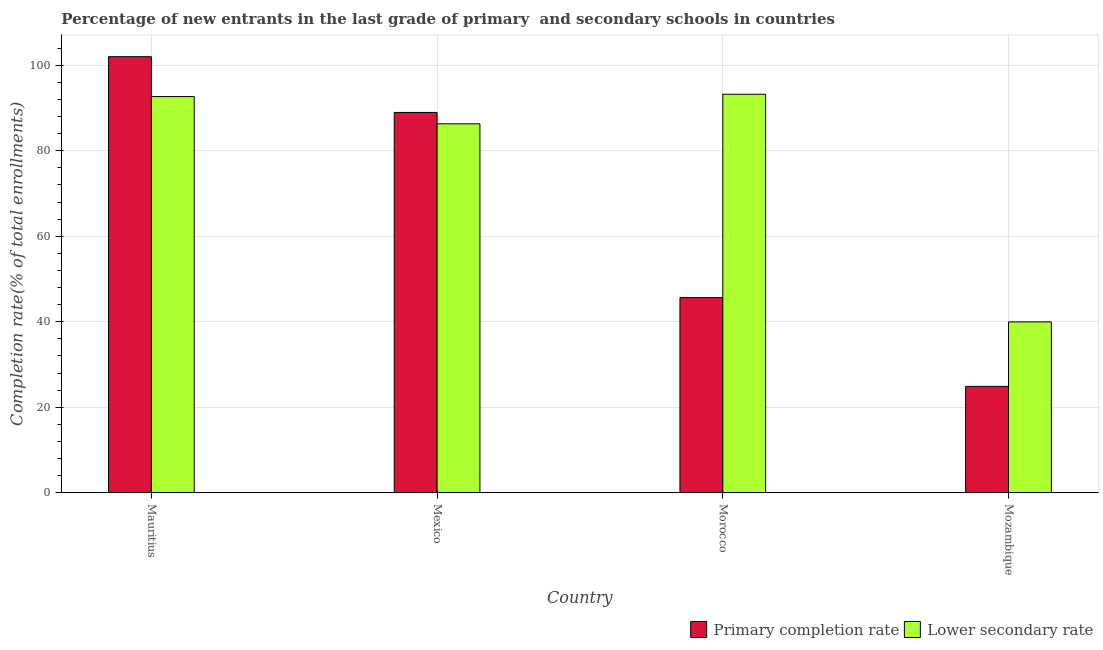Are the number of bars on each tick of the X-axis equal?
Offer a very short reply. Yes. How many bars are there on the 1st tick from the right?
Make the answer very short. 2. What is the completion rate in secondary schools in Morocco?
Your answer should be compact. 93.21. Across all countries, what is the maximum completion rate in secondary schools?
Give a very brief answer. 93.21. Across all countries, what is the minimum completion rate in primary schools?
Offer a terse response. 24.87. In which country was the completion rate in secondary schools maximum?
Keep it short and to the point. Morocco. In which country was the completion rate in secondary schools minimum?
Give a very brief answer. Mozambique. What is the total completion rate in primary schools in the graph?
Make the answer very short. 261.47. What is the difference between the completion rate in primary schools in Morocco and that in Mozambique?
Keep it short and to the point. 20.77. What is the difference between the completion rate in secondary schools in Mexico and the completion rate in primary schools in Mozambique?
Your answer should be compact. 61.42. What is the average completion rate in secondary schools per country?
Keep it short and to the point. 78.03. What is the difference between the completion rate in secondary schools and completion rate in primary schools in Mauritius?
Your answer should be compact. -9.34. In how many countries, is the completion rate in secondary schools greater than 28 %?
Offer a terse response. 4. What is the ratio of the completion rate in primary schools in Mauritius to that in Mexico?
Offer a terse response. 1.15. Is the difference between the completion rate in primary schools in Morocco and Mozambique greater than the difference between the completion rate in secondary schools in Morocco and Mozambique?
Your response must be concise. No. What is the difference between the highest and the second highest completion rate in primary schools?
Offer a very short reply. 13.05. What is the difference between the highest and the lowest completion rate in secondary schools?
Provide a succinct answer. 53.25. Is the sum of the completion rate in primary schools in Morocco and Mozambique greater than the maximum completion rate in secondary schools across all countries?
Provide a succinct answer. No. What does the 1st bar from the left in Mozambique represents?
Offer a terse response. Primary completion rate. What does the 1st bar from the right in Mauritius represents?
Offer a terse response. Lower secondary rate. Are all the bars in the graph horizontal?
Make the answer very short. No. How many countries are there in the graph?
Keep it short and to the point. 4. Are the values on the major ticks of Y-axis written in scientific E-notation?
Make the answer very short. No. Does the graph contain any zero values?
Your answer should be compact. No. Does the graph contain grids?
Ensure brevity in your answer.  Yes. Where does the legend appear in the graph?
Provide a short and direct response. Bottom right. What is the title of the graph?
Give a very brief answer. Percentage of new entrants in the last grade of primary  and secondary schools in countries. Does "Residents" appear as one of the legend labels in the graph?
Offer a terse response. No. What is the label or title of the X-axis?
Offer a very short reply. Country. What is the label or title of the Y-axis?
Offer a very short reply. Completion rate(% of total enrollments). What is the Completion rate(% of total enrollments) in Primary completion rate in Mauritius?
Give a very brief answer. 102. What is the Completion rate(% of total enrollments) of Lower secondary rate in Mauritius?
Keep it short and to the point. 92.66. What is the Completion rate(% of total enrollments) of Primary completion rate in Mexico?
Your response must be concise. 88.95. What is the Completion rate(% of total enrollments) in Lower secondary rate in Mexico?
Your answer should be compact. 86.3. What is the Completion rate(% of total enrollments) of Primary completion rate in Morocco?
Offer a terse response. 45.65. What is the Completion rate(% of total enrollments) of Lower secondary rate in Morocco?
Your answer should be compact. 93.21. What is the Completion rate(% of total enrollments) of Primary completion rate in Mozambique?
Your response must be concise. 24.87. What is the Completion rate(% of total enrollments) in Lower secondary rate in Mozambique?
Ensure brevity in your answer.  39.96. Across all countries, what is the maximum Completion rate(% of total enrollments) of Primary completion rate?
Keep it short and to the point. 102. Across all countries, what is the maximum Completion rate(% of total enrollments) in Lower secondary rate?
Give a very brief answer. 93.21. Across all countries, what is the minimum Completion rate(% of total enrollments) in Primary completion rate?
Offer a very short reply. 24.87. Across all countries, what is the minimum Completion rate(% of total enrollments) of Lower secondary rate?
Your answer should be very brief. 39.96. What is the total Completion rate(% of total enrollments) in Primary completion rate in the graph?
Your answer should be compact. 261.47. What is the total Completion rate(% of total enrollments) in Lower secondary rate in the graph?
Make the answer very short. 312.13. What is the difference between the Completion rate(% of total enrollments) of Primary completion rate in Mauritius and that in Mexico?
Provide a short and direct response. 13.05. What is the difference between the Completion rate(% of total enrollments) in Lower secondary rate in Mauritius and that in Mexico?
Your answer should be very brief. 6.36. What is the difference between the Completion rate(% of total enrollments) of Primary completion rate in Mauritius and that in Morocco?
Make the answer very short. 56.35. What is the difference between the Completion rate(% of total enrollments) of Lower secondary rate in Mauritius and that in Morocco?
Provide a short and direct response. -0.55. What is the difference between the Completion rate(% of total enrollments) in Primary completion rate in Mauritius and that in Mozambique?
Your response must be concise. 77.13. What is the difference between the Completion rate(% of total enrollments) of Lower secondary rate in Mauritius and that in Mozambique?
Keep it short and to the point. 52.7. What is the difference between the Completion rate(% of total enrollments) of Primary completion rate in Mexico and that in Morocco?
Your response must be concise. 43.31. What is the difference between the Completion rate(% of total enrollments) in Lower secondary rate in Mexico and that in Morocco?
Ensure brevity in your answer.  -6.91. What is the difference between the Completion rate(% of total enrollments) in Primary completion rate in Mexico and that in Mozambique?
Keep it short and to the point. 64.08. What is the difference between the Completion rate(% of total enrollments) of Lower secondary rate in Mexico and that in Mozambique?
Keep it short and to the point. 46.34. What is the difference between the Completion rate(% of total enrollments) of Primary completion rate in Morocco and that in Mozambique?
Offer a terse response. 20.77. What is the difference between the Completion rate(% of total enrollments) of Lower secondary rate in Morocco and that in Mozambique?
Your answer should be very brief. 53.25. What is the difference between the Completion rate(% of total enrollments) in Primary completion rate in Mauritius and the Completion rate(% of total enrollments) in Lower secondary rate in Mexico?
Give a very brief answer. 15.7. What is the difference between the Completion rate(% of total enrollments) in Primary completion rate in Mauritius and the Completion rate(% of total enrollments) in Lower secondary rate in Morocco?
Ensure brevity in your answer.  8.79. What is the difference between the Completion rate(% of total enrollments) in Primary completion rate in Mauritius and the Completion rate(% of total enrollments) in Lower secondary rate in Mozambique?
Offer a terse response. 62.04. What is the difference between the Completion rate(% of total enrollments) in Primary completion rate in Mexico and the Completion rate(% of total enrollments) in Lower secondary rate in Morocco?
Provide a short and direct response. -4.26. What is the difference between the Completion rate(% of total enrollments) in Primary completion rate in Mexico and the Completion rate(% of total enrollments) in Lower secondary rate in Mozambique?
Make the answer very short. 48.99. What is the difference between the Completion rate(% of total enrollments) in Primary completion rate in Morocco and the Completion rate(% of total enrollments) in Lower secondary rate in Mozambique?
Your answer should be compact. 5.68. What is the average Completion rate(% of total enrollments) in Primary completion rate per country?
Provide a short and direct response. 65.37. What is the average Completion rate(% of total enrollments) in Lower secondary rate per country?
Your answer should be very brief. 78.03. What is the difference between the Completion rate(% of total enrollments) of Primary completion rate and Completion rate(% of total enrollments) of Lower secondary rate in Mauritius?
Ensure brevity in your answer.  9.34. What is the difference between the Completion rate(% of total enrollments) in Primary completion rate and Completion rate(% of total enrollments) in Lower secondary rate in Mexico?
Your answer should be very brief. 2.65. What is the difference between the Completion rate(% of total enrollments) of Primary completion rate and Completion rate(% of total enrollments) of Lower secondary rate in Morocco?
Ensure brevity in your answer.  -47.57. What is the difference between the Completion rate(% of total enrollments) of Primary completion rate and Completion rate(% of total enrollments) of Lower secondary rate in Mozambique?
Make the answer very short. -15.09. What is the ratio of the Completion rate(% of total enrollments) in Primary completion rate in Mauritius to that in Mexico?
Give a very brief answer. 1.15. What is the ratio of the Completion rate(% of total enrollments) in Lower secondary rate in Mauritius to that in Mexico?
Offer a terse response. 1.07. What is the ratio of the Completion rate(% of total enrollments) of Primary completion rate in Mauritius to that in Morocco?
Your answer should be very brief. 2.23. What is the ratio of the Completion rate(% of total enrollments) of Lower secondary rate in Mauritius to that in Morocco?
Your answer should be very brief. 0.99. What is the ratio of the Completion rate(% of total enrollments) of Primary completion rate in Mauritius to that in Mozambique?
Keep it short and to the point. 4.1. What is the ratio of the Completion rate(% of total enrollments) in Lower secondary rate in Mauritius to that in Mozambique?
Keep it short and to the point. 2.32. What is the ratio of the Completion rate(% of total enrollments) in Primary completion rate in Mexico to that in Morocco?
Your response must be concise. 1.95. What is the ratio of the Completion rate(% of total enrollments) in Lower secondary rate in Mexico to that in Morocco?
Your answer should be very brief. 0.93. What is the ratio of the Completion rate(% of total enrollments) in Primary completion rate in Mexico to that in Mozambique?
Your answer should be very brief. 3.58. What is the ratio of the Completion rate(% of total enrollments) of Lower secondary rate in Mexico to that in Mozambique?
Keep it short and to the point. 2.16. What is the ratio of the Completion rate(% of total enrollments) of Primary completion rate in Morocco to that in Mozambique?
Your response must be concise. 1.84. What is the ratio of the Completion rate(% of total enrollments) in Lower secondary rate in Morocco to that in Mozambique?
Give a very brief answer. 2.33. What is the difference between the highest and the second highest Completion rate(% of total enrollments) of Primary completion rate?
Your response must be concise. 13.05. What is the difference between the highest and the second highest Completion rate(% of total enrollments) of Lower secondary rate?
Offer a terse response. 0.55. What is the difference between the highest and the lowest Completion rate(% of total enrollments) in Primary completion rate?
Keep it short and to the point. 77.13. What is the difference between the highest and the lowest Completion rate(% of total enrollments) of Lower secondary rate?
Provide a succinct answer. 53.25. 